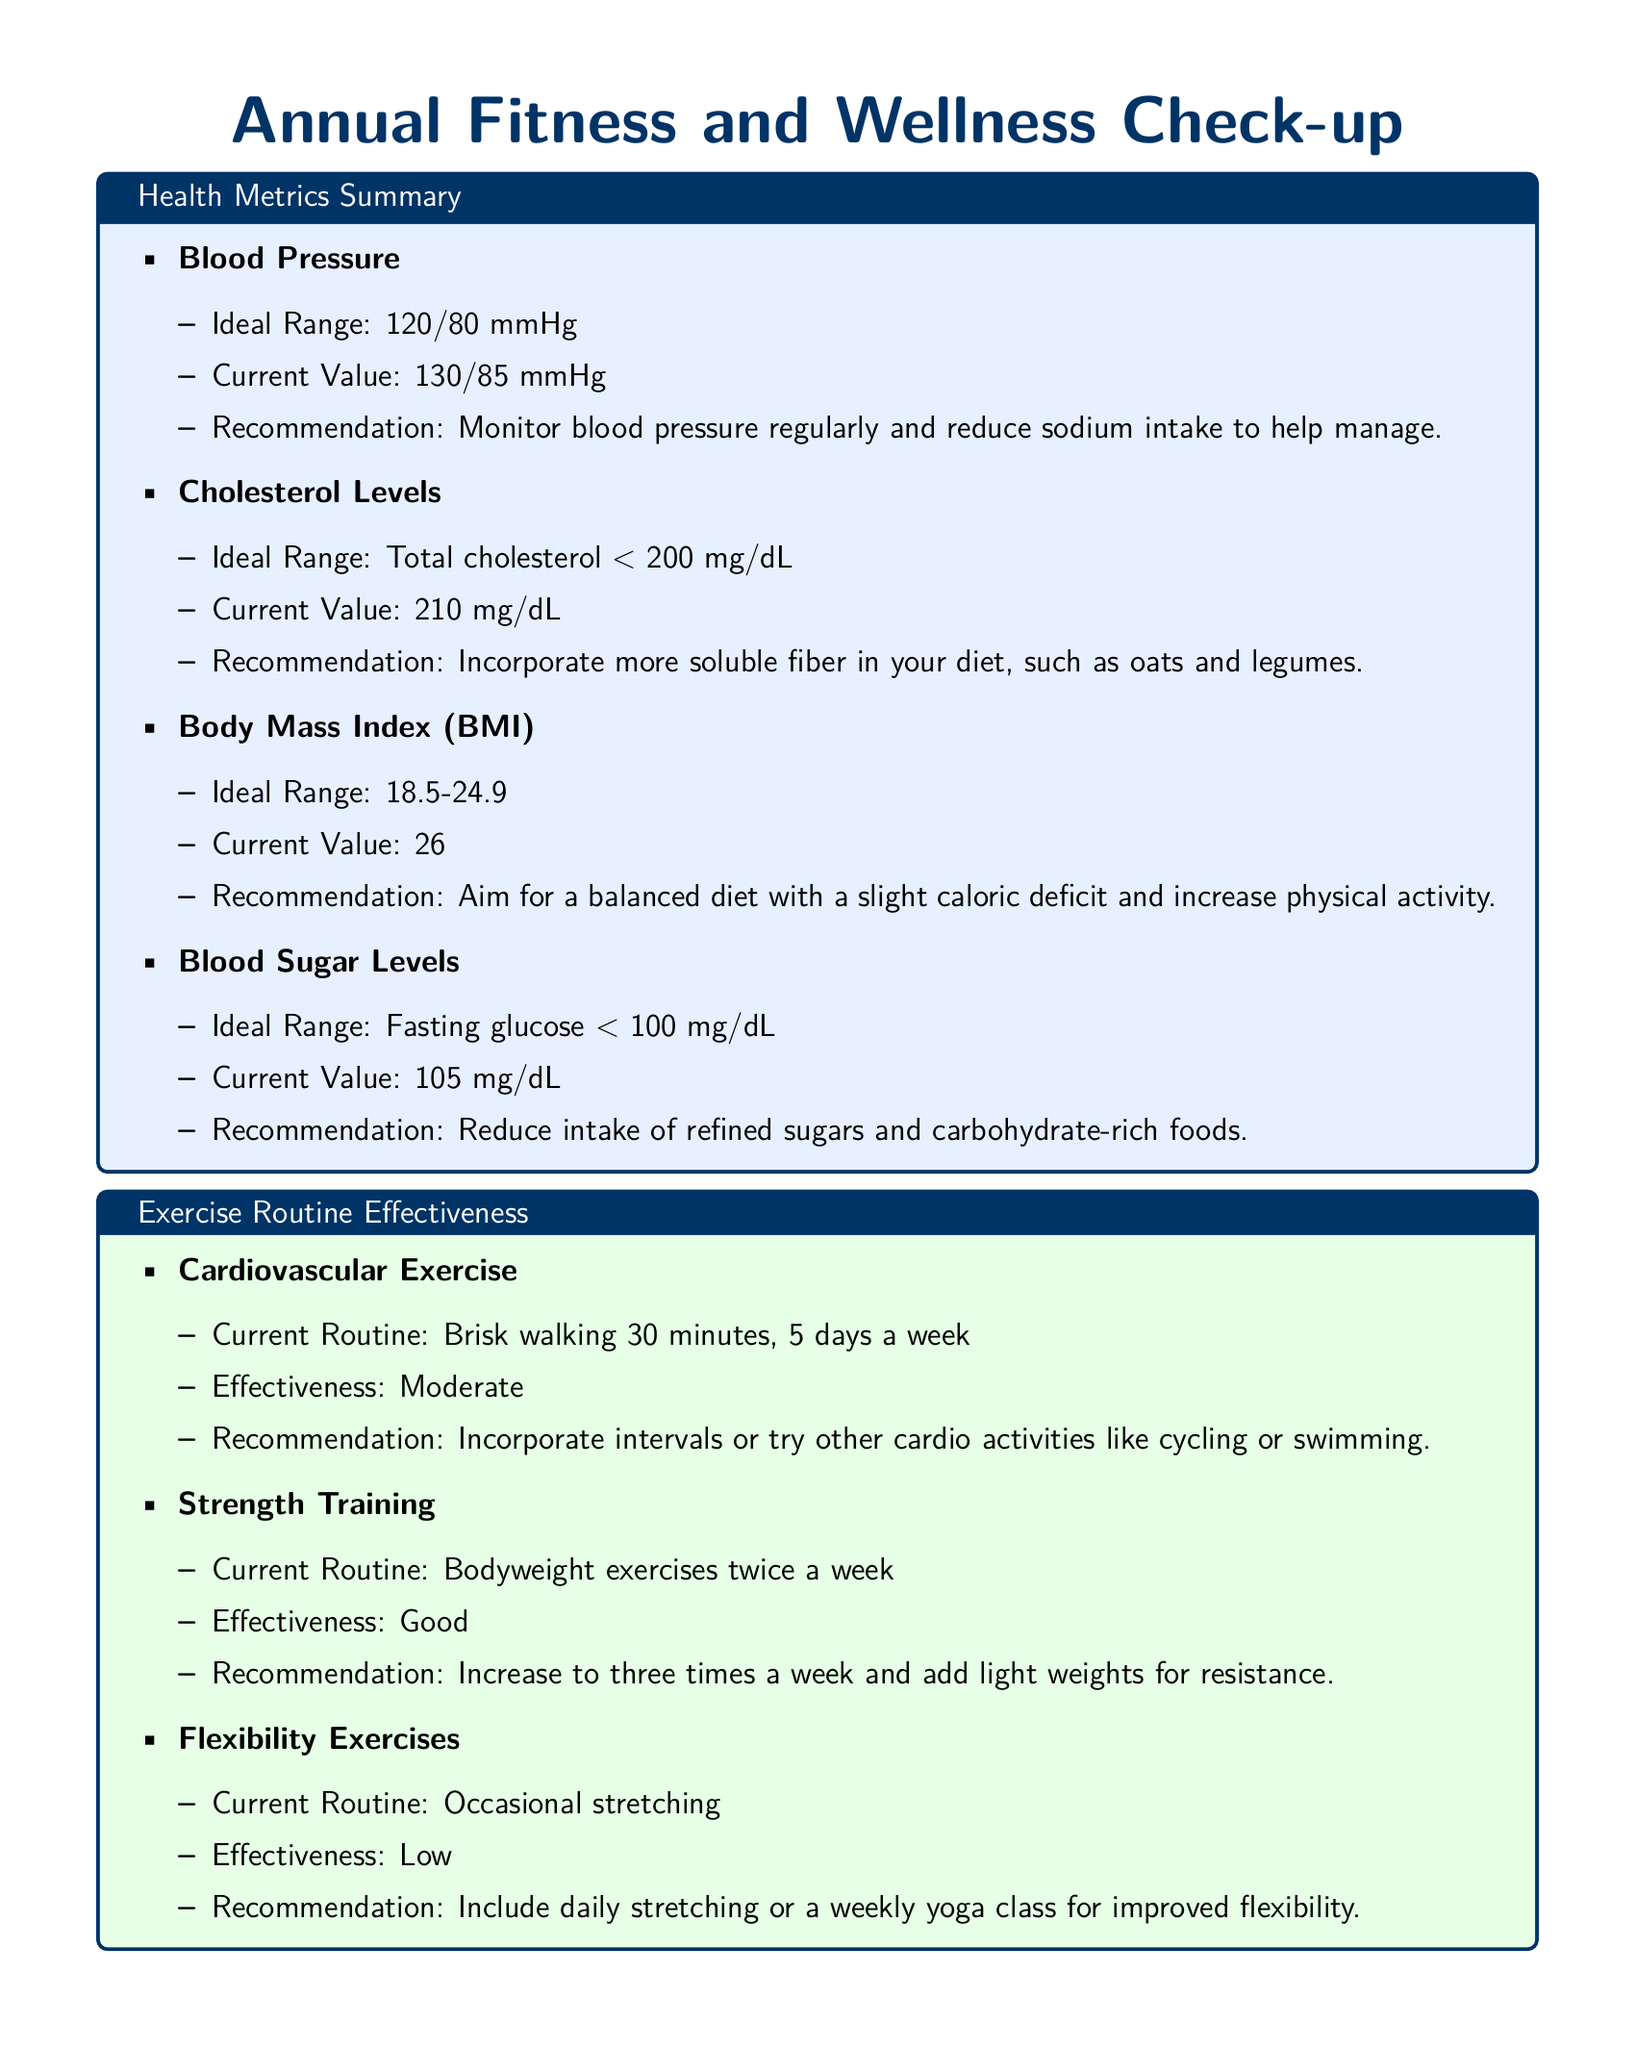What is the ideal range for blood pressure? The ideal range for blood pressure is specified in the document as 120/80 mmHg.
Answer: 120/80 mmHg What recommendation is given for cholesterol levels? The document recommends to incorporate more soluble fiber in your diet, such as oats and legumes for cholesterol levels.
Answer: Incorporate more soluble fiber in your diet, such as oats and legumes What is the current value of Body Mass Index (BMI)? The current value for Body Mass Index (BMI) listed in the document is 26.
Answer: 26 How many days a week is cardiovascular exercise recommended? The document states the recommendation for cardiovascular exercise is 5 days a week of brisk walking.
Answer: 5 days a week What is the effectiveness rating for strength training? The document rates the effectiveness of strength training as Good.
Answer: Good What improvement area has a recommendation to track eating habits? The document indicates that the improvement area related to tracking eating habits is Diet and Nutrition.
Answer: Diet and Nutrition What is advised to improve sleep quality? The document advises to establish a regular sleep schedule and create a relaxing bedtime routine for sleep quality improvement.
Answer: Establish a regular sleep schedule and create a relaxing bedtime routine How many glasses of water is suggested for hydration? The suggested amount of water intake for hydration in the document is at least 8 glasses per day.
Answer: At least 8 glasses What exercise type is recommended to include daily for improved flexibility? The document recommends including daily stretching to improve flexibility.
Answer: Daily stretching 